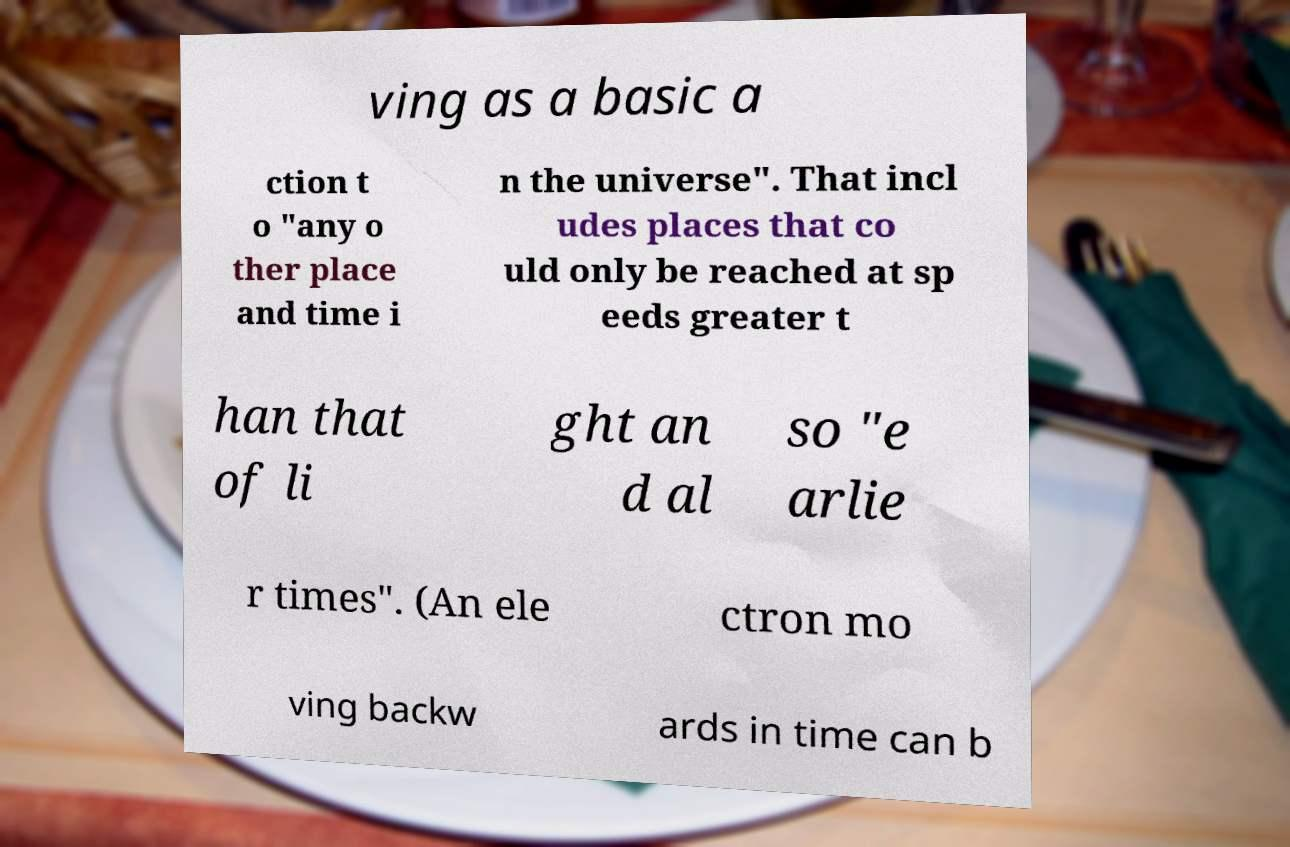Can you accurately transcribe the text from the provided image for me? ving as a basic a ction t o "any o ther place and time i n the universe". That incl udes places that co uld only be reached at sp eeds greater t han that of li ght an d al so "e arlie r times". (An ele ctron mo ving backw ards in time can b 